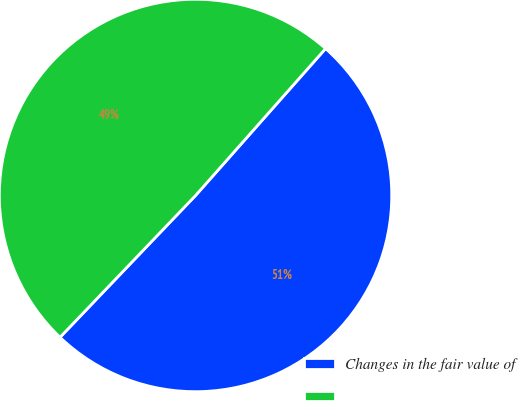Convert chart. <chart><loc_0><loc_0><loc_500><loc_500><pie_chart><fcel>Changes in the fair value of<fcel>Unnamed: 1<nl><fcel>50.61%<fcel>49.39%<nl></chart> 